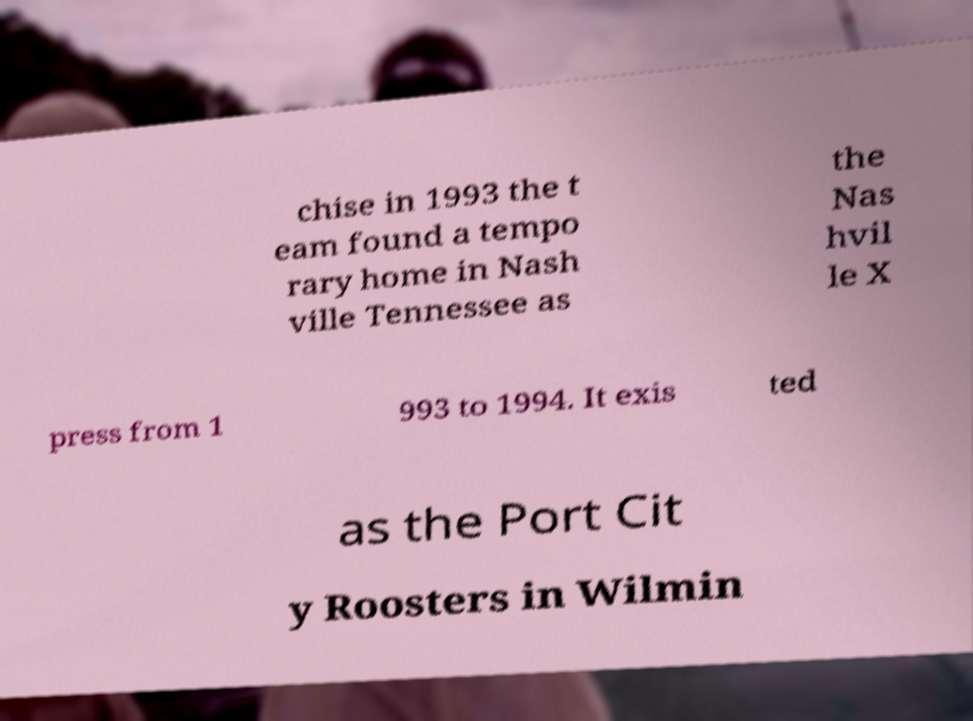Can you read and provide the text displayed in the image?This photo seems to have some interesting text. Can you extract and type it out for me? chise in 1993 the t eam found a tempo rary home in Nash ville Tennessee as the Nas hvil le X press from 1 993 to 1994. It exis ted as the Port Cit y Roosters in Wilmin 